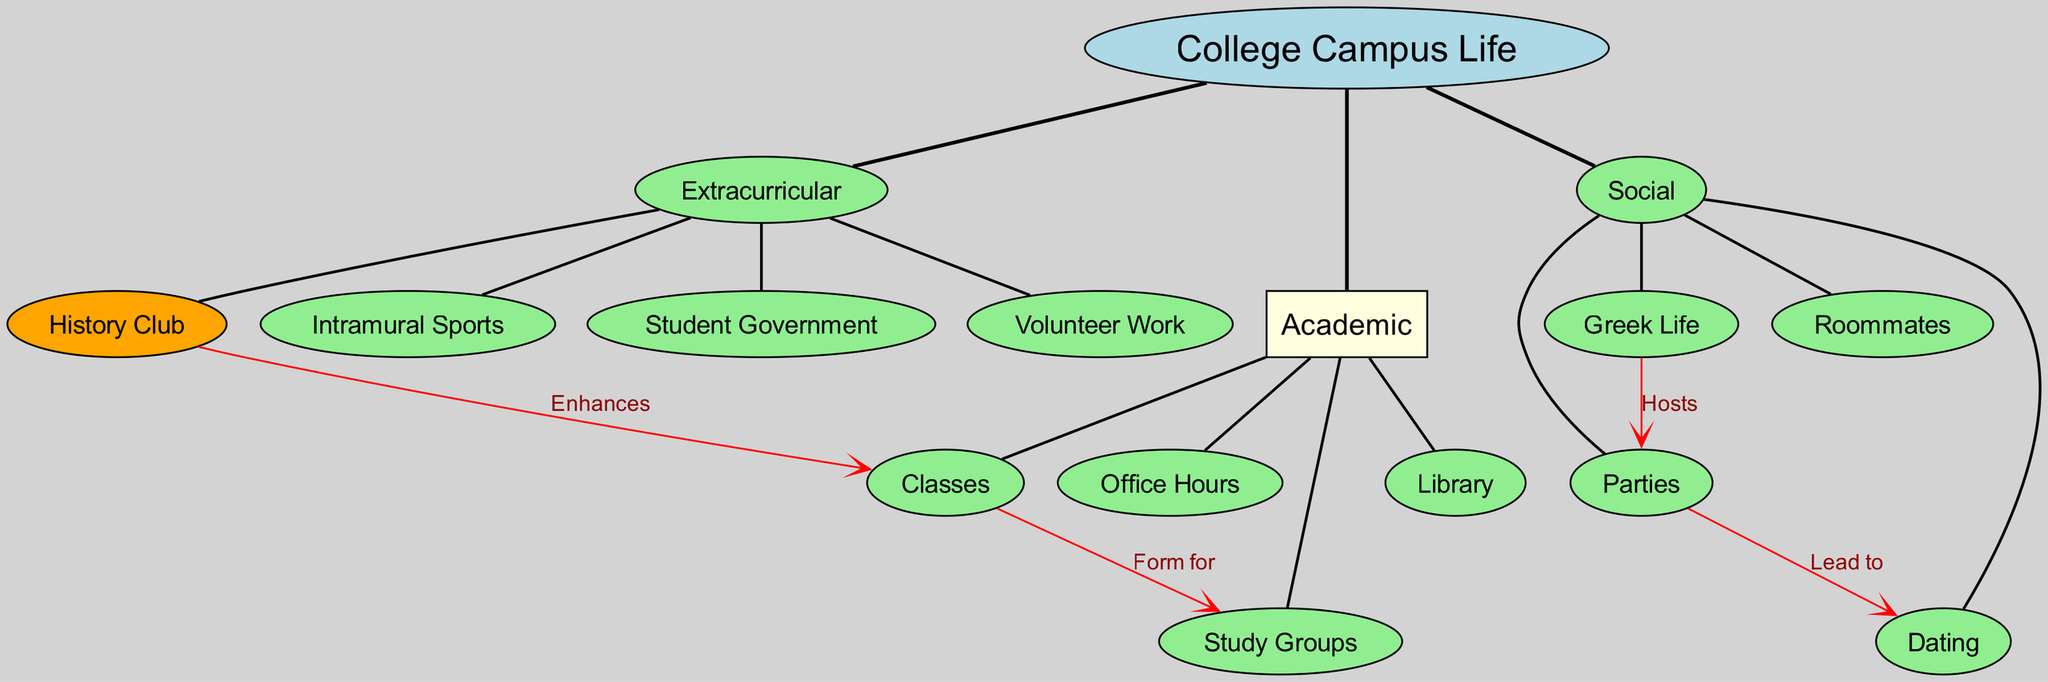What is the central concept of the diagram? The central concept is explicitly labeled in the diagram as "College Campus Life." It is the main focus from which all branches originate.
Answer: College Campus Life How many main branches are present? The diagram shows three main branches: Academic, Social, and Extracurricular. This can be counted directly from the main branches section.
Answer: 3 What leads to dating according to the diagram? By looking at the connections in the diagram, it is clear that "Parties" leads to "Dating." This relationship is indicated by a labeled edge connecting the two nodes.
Answer: Parties Which branch hosts parties? The diagram indicates that "Greek Life" is the branch that hosts "Parties." This is seen through the directed connection labeled "Hosts" from Greek Life to Parties.
Answer: Greek Life What enhances classes in this diagram? The "History Club" enhances "Classes," as indicated by the edge labeled "Enhances" that connects the two nodes. This shows a supportive relationship between these two elements.
Answer: History Club Name one activity that falls under extracurricular aspects. Based on the sub-branches listed under the Extracurricular main branch, possible activities include "History Club," "Intramural Sports," "Student Government," or "Volunteer Work." Any of these are valid answers.
Answer: History Club How many sub-branches are in the Academic category? The Academic branch consists of four sub-branches: Classes, Library, Study Groups, and Office Hours. This can be counted directly from the list of sub-branches under Academic.
Answer: 4 What is the relationship between Classes and Study Groups? The relationship is established in the diagram where "Classes" form for "Study Groups," as indicated by the directed edge labeled "Form for." This connection shows that study groups are created as a result of classes.
Answer: Form for Which two elements are connected by the term 'Hosts'? The term 'Hosts' connects "Greek Life" to "Parties," as seen in the diagram where the edge is clearly labeled with this term. This indicates the responsibility of Greek Life in organizing parties.
Answer: Greek Life and Parties 